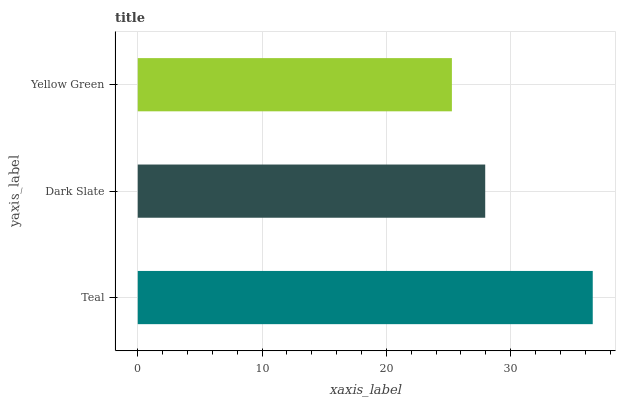Is Yellow Green the minimum?
Answer yes or no. Yes. Is Teal the maximum?
Answer yes or no. Yes. Is Dark Slate the minimum?
Answer yes or no. No. Is Dark Slate the maximum?
Answer yes or no. No. Is Teal greater than Dark Slate?
Answer yes or no. Yes. Is Dark Slate less than Teal?
Answer yes or no. Yes. Is Dark Slate greater than Teal?
Answer yes or no. No. Is Teal less than Dark Slate?
Answer yes or no. No. Is Dark Slate the high median?
Answer yes or no. Yes. Is Dark Slate the low median?
Answer yes or no. Yes. Is Yellow Green the high median?
Answer yes or no. No. Is Yellow Green the low median?
Answer yes or no. No. 